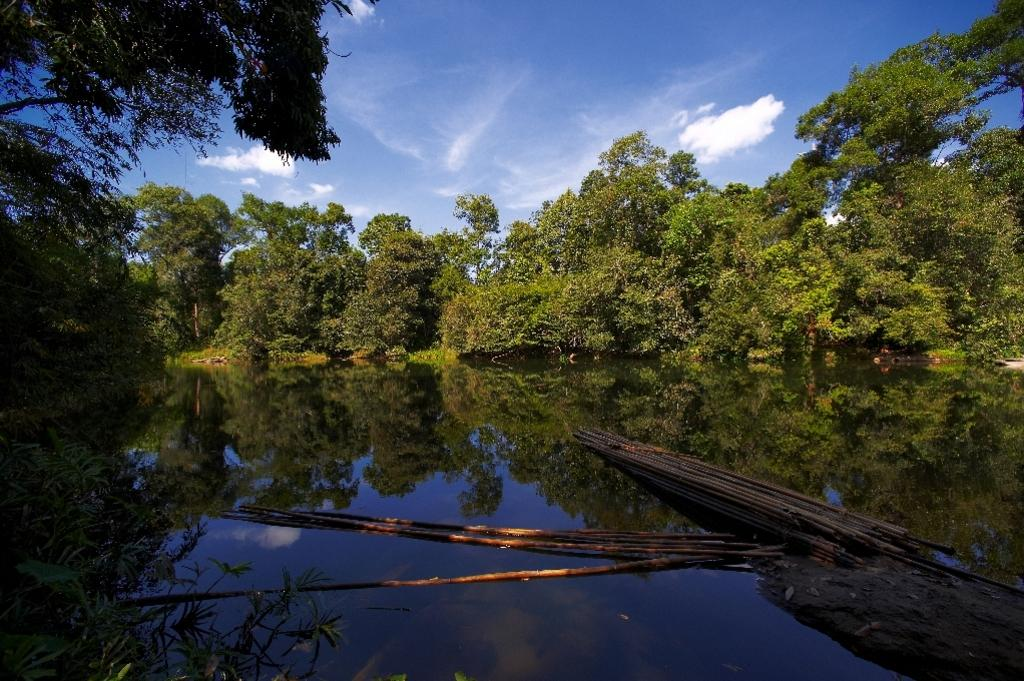What is the main subject in the center of the image? There is water in the center of the image. What is floating on the water? There are stocks on the water. What can be seen in the background of the image? There are trees and the sky visible in the background of the image. What type of pail is being used to reason with the stocks in the image? There is no pail present in the image, and the stocks are not being reasoned with. 